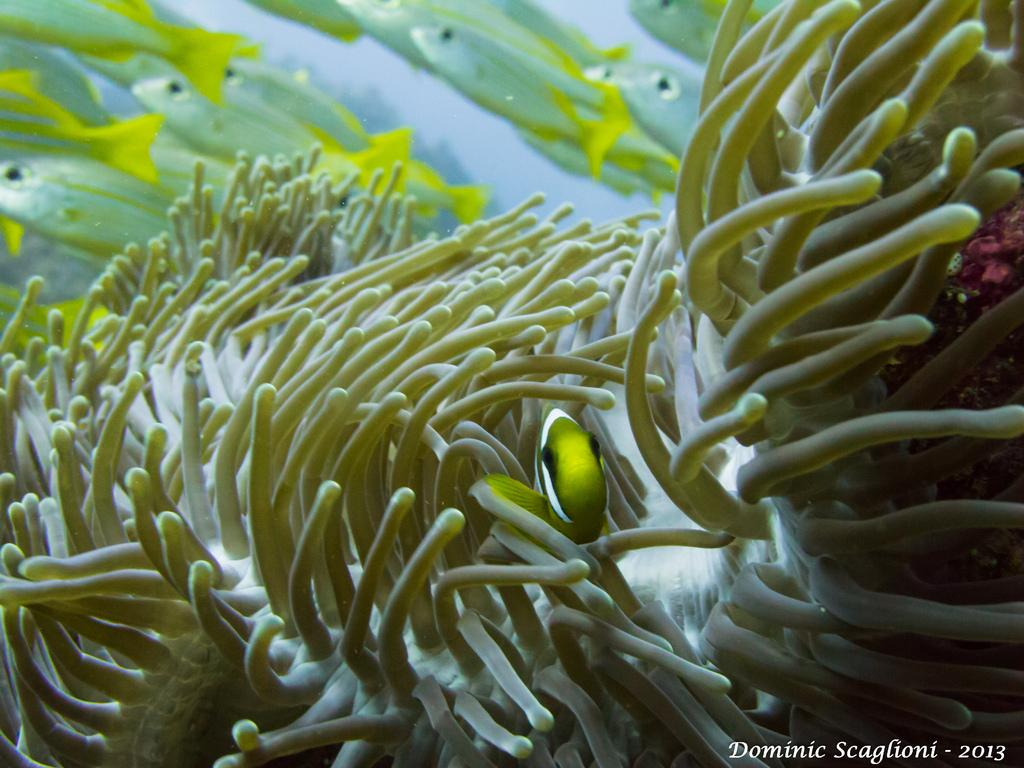What type of plants are visible in the image? There are sea plants in the image. What other living organisms can be seen in the image? There are fishes in the image. What type of rat can be seen interacting with the sea plants in the image? There is no rat present in the image; it features sea plants and fishes. What type of wealth can be observed in the image? The image does not depict any wealth or financial assets; it focuses on sea plants and fishes. 